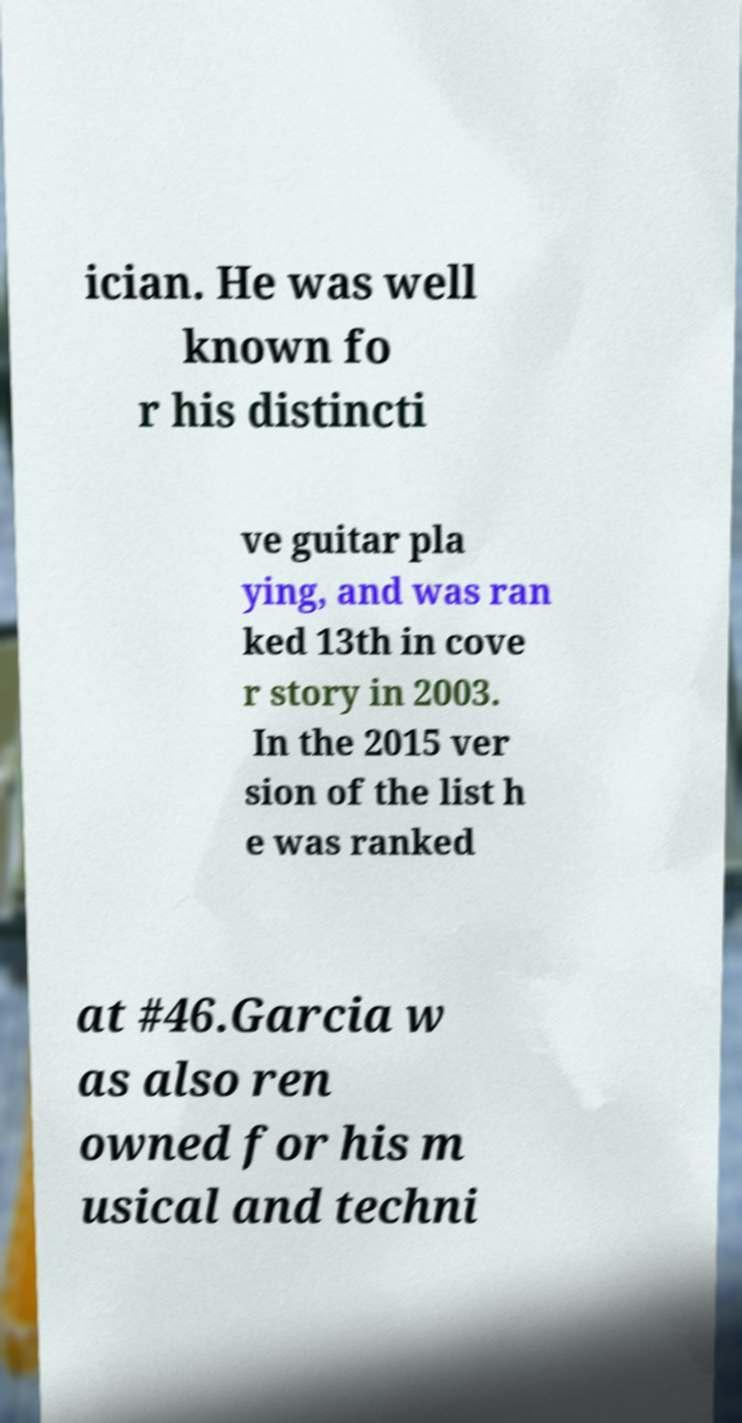For documentation purposes, I need the text within this image transcribed. Could you provide that? ician. He was well known fo r his distincti ve guitar pla ying, and was ran ked 13th in cove r story in 2003. In the 2015 ver sion of the list h e was ranked at #46.Garcia w as also ren owned for his m usical and techni 